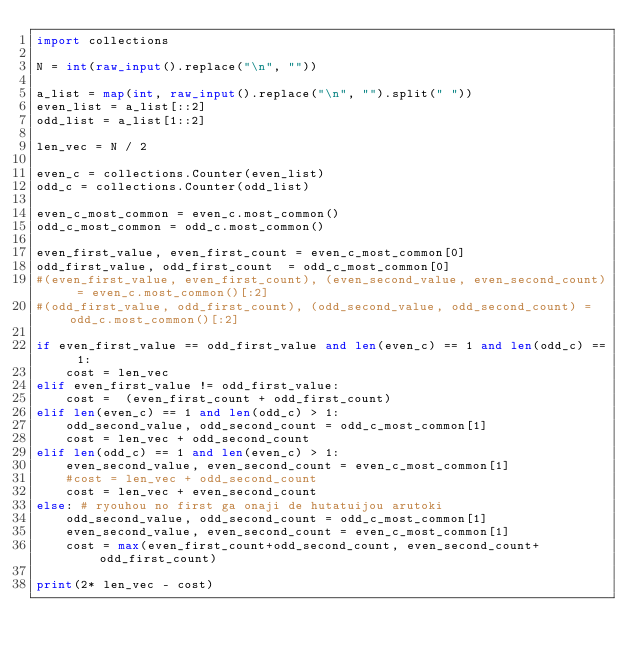Convert code to text. <code><loc_0><loc_0><loc_500><loc_500><_Python_>import collections

N = int(raw_input().replace("\n", ""))

a_list = map(int, raw_input().replace("\n", "").split(" "))
even_list = a_list[::2]
odd_list = a_list[1::2]

len_vec = N / 2

even_c = collections.Counter(even_list)
odd_c = collections.Counter(odd_list)

even_c_most_common = even_c.most_common()
odd_c_most_common = odd_c.most_common()

even_first_value, even_first_count = even_c_most_common[0]
odd_first_value, odd_first_count  = odd_c_most_common[0]
#(even_first_value, even_first_count), (even_second_value, even_second_count) = even_c.most_common()[:2]
#(odd_first_value, odd_first_count), (odd_second_value, odd_second_count) = odd_c.most_common()[:2]

if even_first_value == odd_first_value and len(even_c) == 1 and len(odd_c) == 1:
    cost = len_vec
elif even_first_value != odd_first_value:
    cost =  (even_first_count + odd_first_count)
elif len(even_c) == 1 and len(odd_c) > 1:
    odd_second_value, odd_second_count = odd_c_most_common[1]
    cost = len_vec + odd_second_count
elif len(odd_c) == 1 and len(even_c) > 1:
    even_second_value, even_second_count = even_c_most_common[1]
    #cost = len_vec + odd_second_count
    cost = len_vec + even_second_count
else: # ryouhou no first ga onaji de hutatuijou arutoki
    odd_second_value, odd_second_count = odd_c_most_common[1]
    even_second_value, even_second_count = even_c_most_common[1]
    cost = max(even_first_count+odd_second_count, even_second_count+odd_first_count)

print(2* len_vec - cost)</code> 